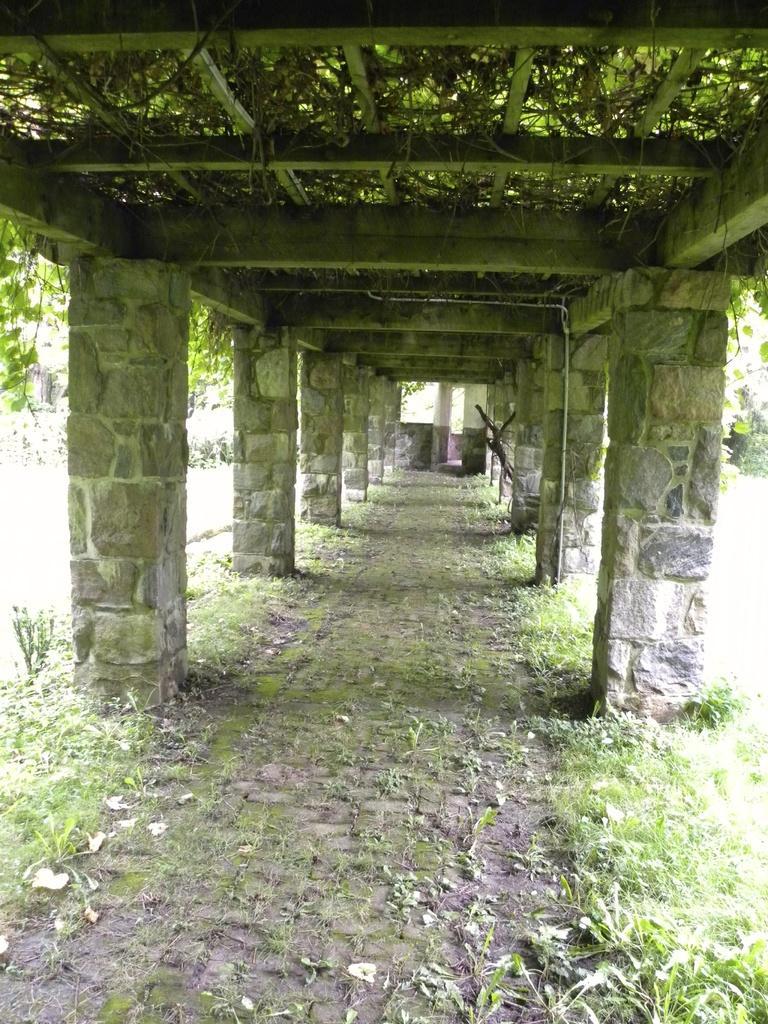Describe this image in one or two sentences. In this image we can see the pathway under a roof. We can also see some pillars, the creepers, plants and grass on the ground. 